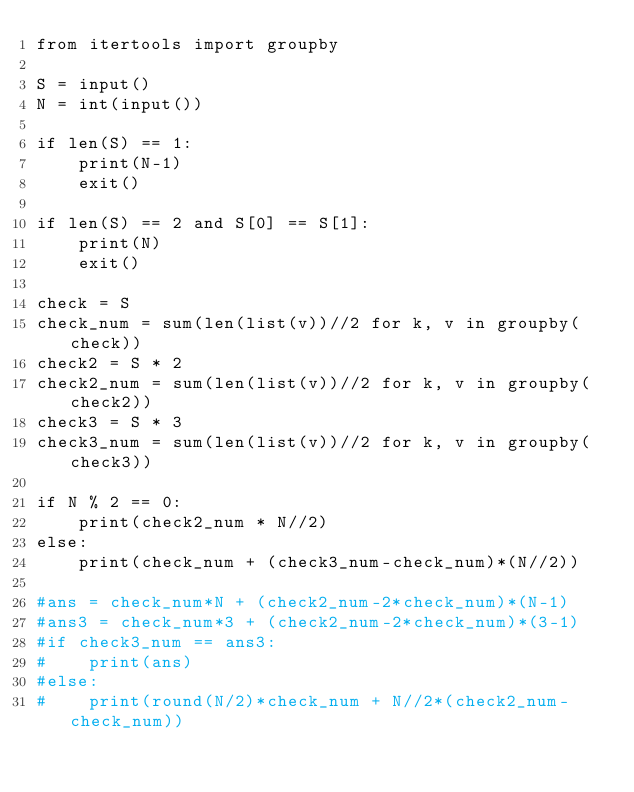<code> <loc_0><loc_0><loc_500><loc_500><_Python_>from itertools import groupby

S = input()
N = int(input())

if len(S) == 1:
    print(N-1)
    exit()

if len(S) == 2 and S[0] == S[1]:
    print(N)
    exit()

check = S
check_num = sum(len(list(v))//2 for k, v in groupby(check))
check2 = S * 2
check2_num = sum(len(list(v))//2 for k, v in groupby(check2))
check3 = S * 3
check3_num = sum(len(list(v))//2 for k, v in groupby(check3))

if N % 2 == 0:
    print(check2_num * N//2)
else:
    print(check_num + (check3_num-check_num)*(N//2))

#ans = check_num*N + (check2_num-2*check_num)*(N-1)
#ans3 = check_num*3 + (check2_num-2*check_num)*(3-1)
#if check3_num == ans3:
#    print(ans)
#else:
#    print(round(N/2)*check_num + N//2*(check2_num-check_num))
</code> 